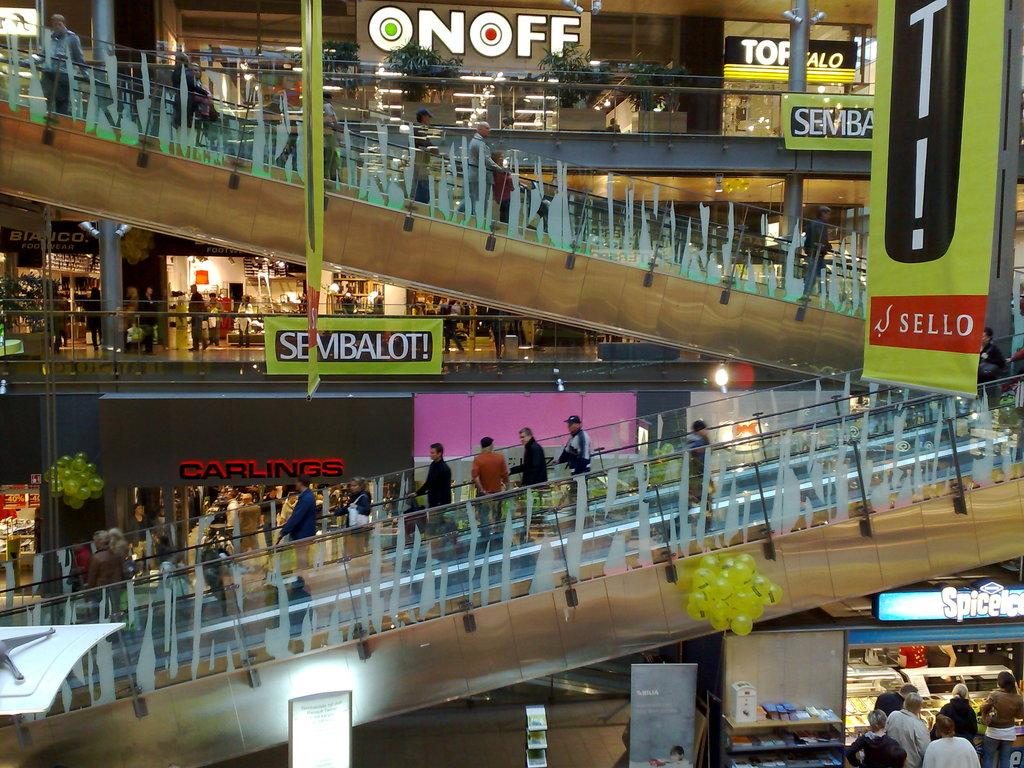What type of location is depicted in the image? The image shows an inside view of a building. Can you describe the people in the image? There is a group of people in the image. What type of transportation is available in the building? Escalators are present in the image. What can be seen on the walls or displayed in the image? Boards and banners are present in the image. What type of lighting is used in the building? Lights are present in the image. What type of businesses or services are available in the building? Shops are visible in the image. What additional decorative elements are present in the image? Balloons and plants are present in the image. Are there any other objects or features in the image? There are other objects in the image. Can you tell me where the monkey is sitting with the tray in the image? There is no monkey or tray present in the image. What advice would the aunt give to the group of people in the image? There is no aunt present in the image, so it's not possible to determine what advice she might give. 